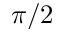<formula> <loc_0><loc_0><loc_500><loc_500>\pi / 2</formula> 